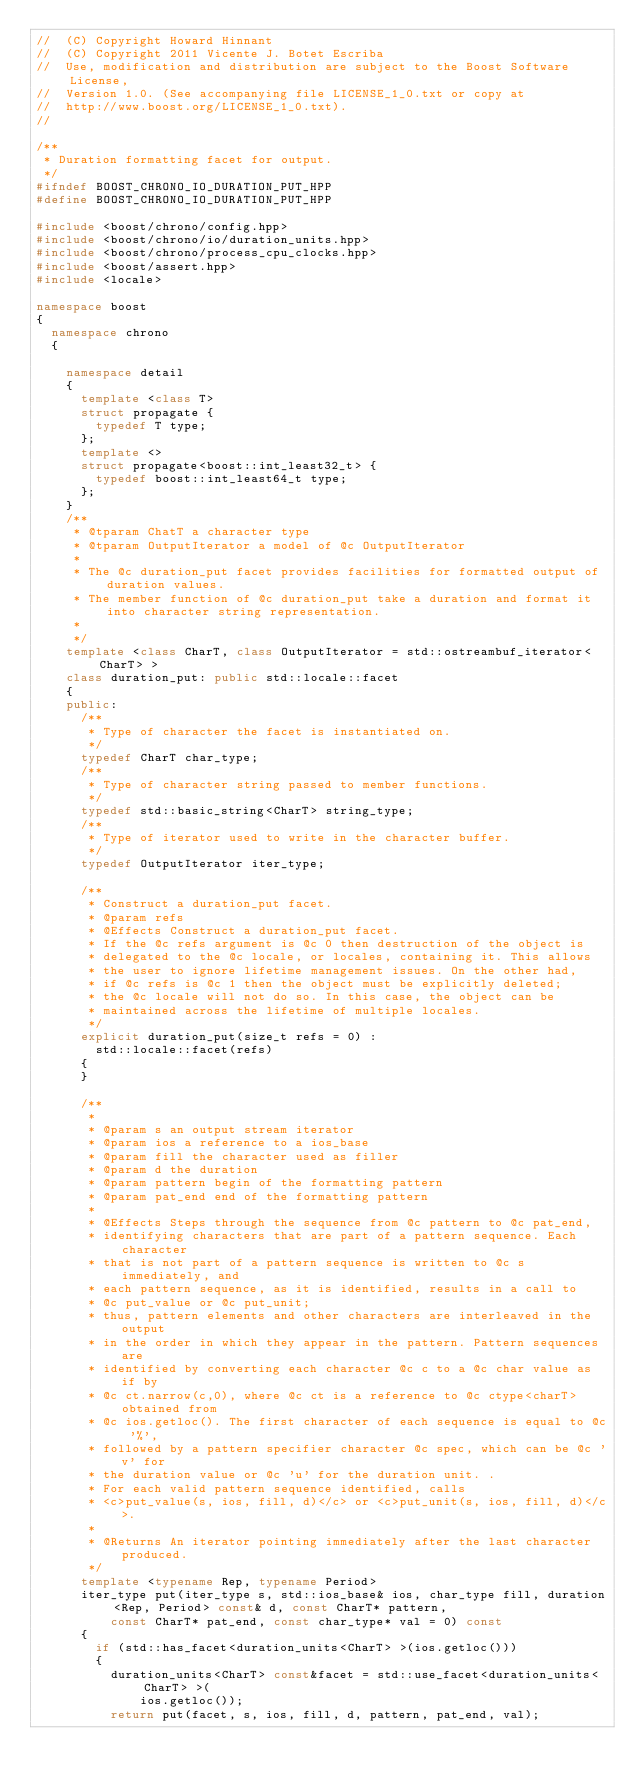Convert code to text. <code><loc_0><loc_0><loc_500><loc_500><_C++_>//  (C) Copyright Howard Hinnant
//  (C) Copyright 2011 Vicente J. Botet Escriba
//  Use, modification and distribution are subject to the Boost Software License,
//  Version 1.0. (See accompanying file LICENSE_1_0.txt or copy at
//  http://www.boost.org/LICENSE_1_0.txt).
//

/**
 * Duration formatting facet for output.
 */
#ifndef BOOST_CHRONO_IO_DURATION_PUT_HPP
#define BOOST_CHRONO_IO_DURATION_PUT_HPP

#include <boost/chrono/config.hpp>
#include <boost/chrono/io/duration_units.hpp>
#include <boost/chrono/process_cpu_clocks.hpp>
#include <boost/assert.hpp>
#include <locale>

namespace boost
{
  namespace chrono
  {

    namespace detail
    {
      template <class T>
      struct propagate {
        typedef T type;
      };
      template <>
      struct propagate<boost::int_least32_t> {
        typedef boost::int_least64_t type;
      };
    }
    /**
     * @tparam ChatT a character type
     * @tparam OutputIterator a model of @c OutputIterator
     *
     * The @c duration_put facet provides facilities for formatted output of duration values.
     * The member function of @c duration_put take a duration and format it into character string representation.
     *
     */
    template <class CharT, class OutputIterator = std::ostreambuf_iterator<CharT> >
    class duration_put: public std::locale::facet
    {
    public:
      /**
       * Type of character the facet is instantiated on.
       */
      typedef CharT char_type;
      /**
       * Type of character string passed to member functions.
       */
      typedef std::basic_string<CharT> string_type;
      /**
       * Type of iterator used to write in the character buffer.
       */
      typedef OutputIterator iter_type;

      /**
       * Construct a duration_put facet.
       * @param refs
       * @Effects Construct a duration_put facet.
       * If the @c refs argument is @c 0 then destruction of the object is
       * delegated to the @c locale, or locales, containing it. This allows
       * the user to ignore lifetime management issues. On the other had,
       * if @c refs is @c 1 then the object must be explicitly deleted;
       * the @c locale will not do so. In this case, the object can be
       * maintained across the lifetime of multiple locales.
       */
      explicit duration_put(size_t refs = 0) :
        std::locale::facet(refs)
      {
      }

      /**
       *
       * @param s an output stream iterator
       * @param ios a reference to a ios_base
       * @param fill the character used as filler
       * @param d the duration
       * @param pattern begin of the formatting pattern
       * @param pat_end end of the formatting pattern
       *
       * @Effects Steps through the sequence from @c pattern to @c pat_end,
       * identifying characters that are part of a pattern sequence. Each character
       * that is not part of a pattern sequence is written to @c s immediately, and
       * each pattern sequence, as it is identified, results in a call to
       * @c put_value or @c put_unit;
       * thus, pattern elements and other characters are interleaved in the output
       * in the order in which they appear in the pattern. Pattern sequences are
       * identified by converting each character @c c to a @c char value as if by
       * @c ct.narrow(c,0), where @c ct is a reference to @c ctype<charT> obtained from
       * @c ios.getloc(). The first character of each sequence is equal to @c '%',
       * followed by a pattern specifier character @c spec, which can be @c 'v' for
       * the duration value or @c 'u' for the duration unit. .
       * For each valid pattern sequence identified, calls
       * <c>put_value(s, ios, fill, d)</c> or <c>put_unit(s, ios, fill, d)</c>.
       *
       * @Returns An iterator pointing immediately after the last character produced.
       */
      template <typename Rep, typename Period>
      iter_type put(iter_type s, std::ios_base& ios, char_type fill, duration<Rep, Period> const& d, const CharT* pattern,
          const CharT* pat_end, const char_type* val = 0) const
      {
        if (std::has_facet<duration_units<CharT> >(ios.getloc()))
        {
          duration_units<CharT> const&facet = std::use_facet<duration_units<CharT> >(
              ios.getloc());
          return put(facet, s, ios, fill, d, pattern, pat_end, val);</code> 